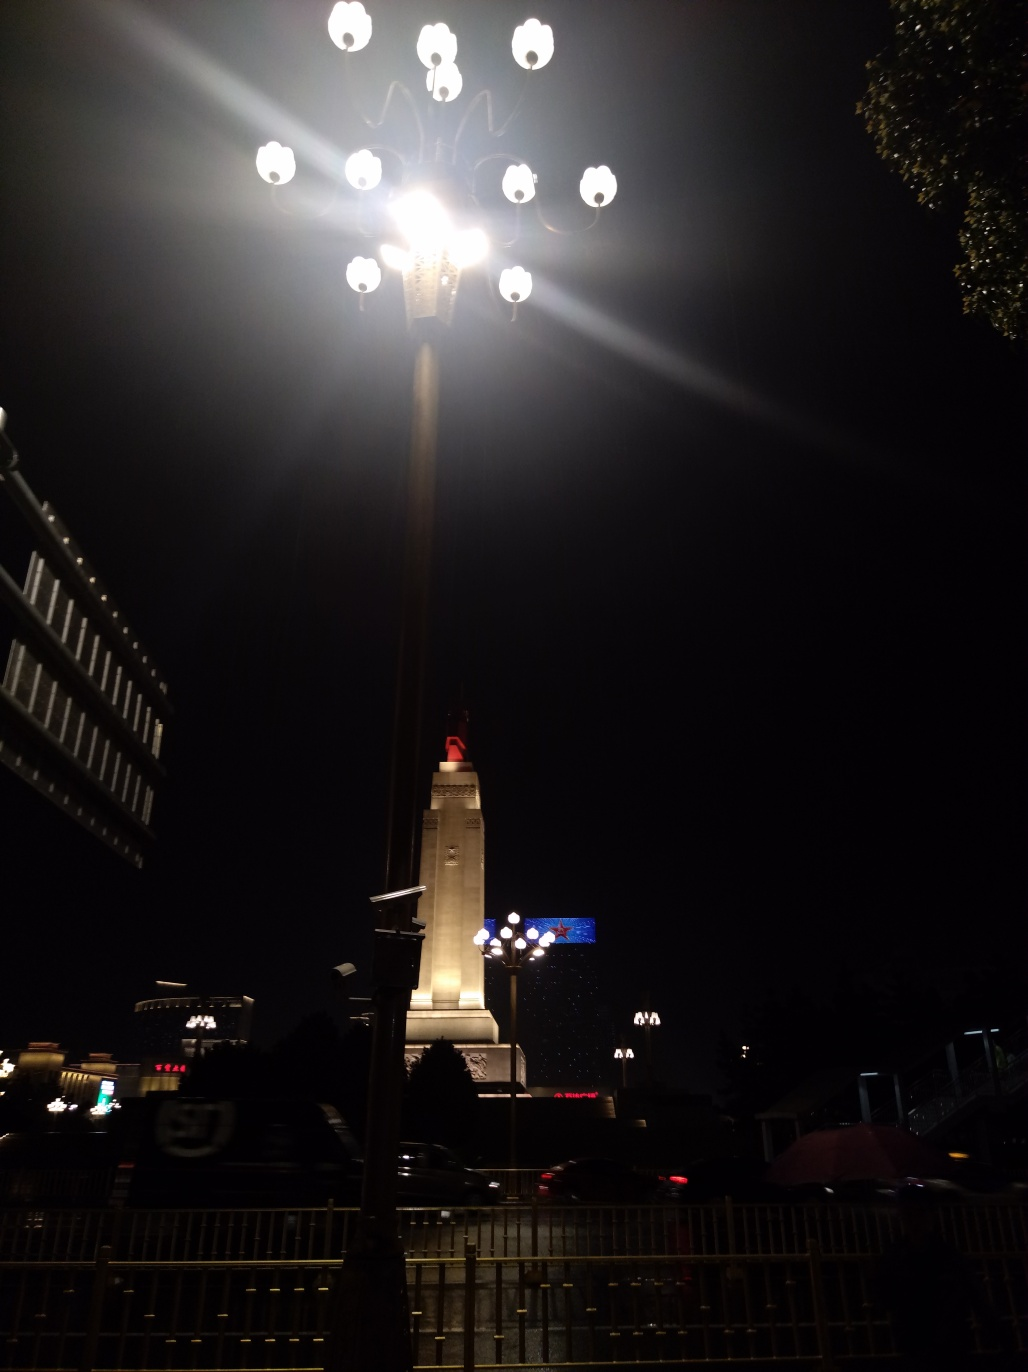What kind of weather conditions can you interpret from the photo? The lack of visible precipitation or strong wind, and the clarity of the structures and lights suggest calm weather conditions at the time the photo was taken. There is also no evidence of fog or mist, further indicating clear weather at night. 